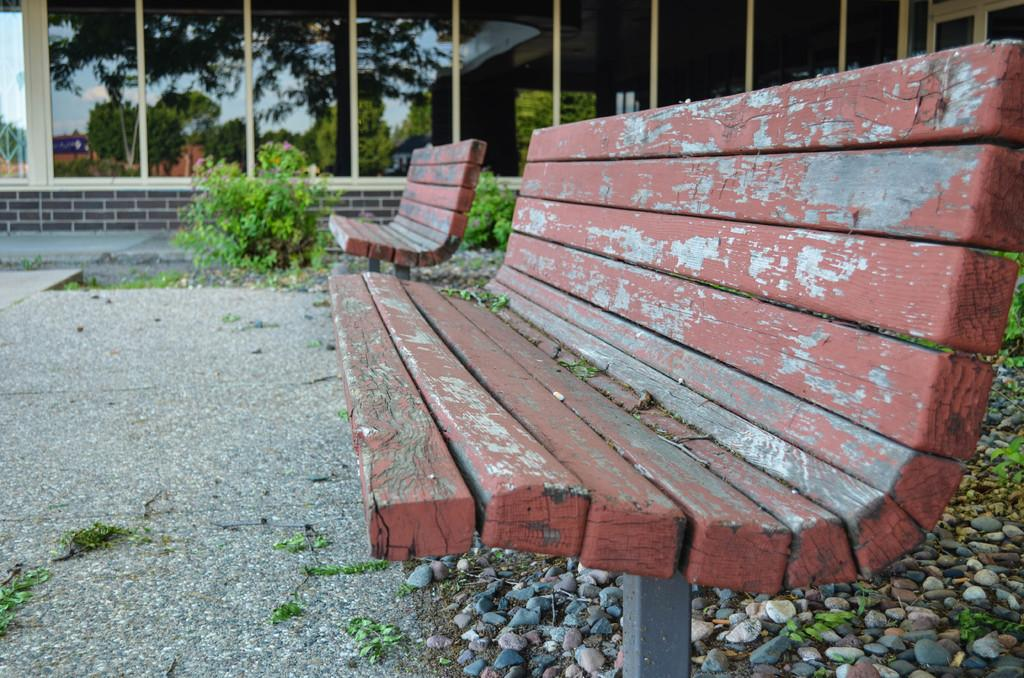What objects are in the foreground of the image? There are two benches in the foreground of the image. Where are the benches located? The benches are on the ground. What can be seen in the background of the image? There are plants, stones, and a glass in the background of the image. How many horses are visible in the image? There are no horses present in the image. What type of hope can be seen in the image? There is no representation of hope in the image; it features two benches, plants, stones, and a glass. 